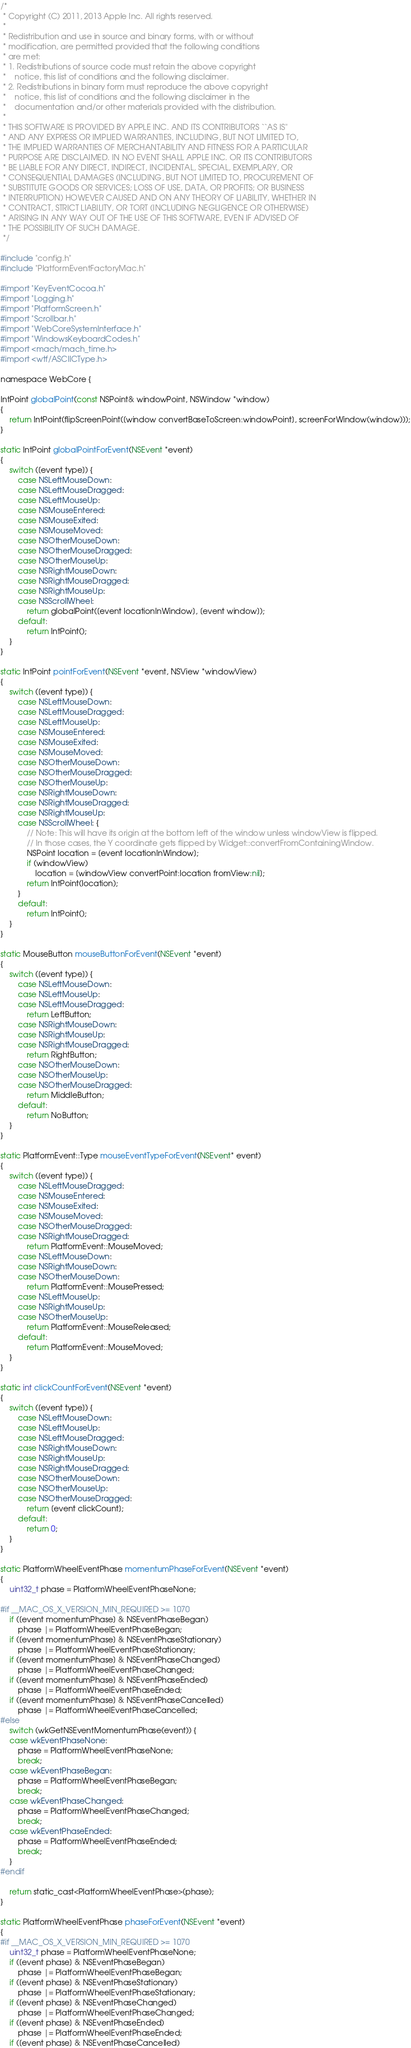Convert code to text. <code><loc_0><loc_0><loc_500><loc_500><_ObjectiveC_>/*
 * Copyright (C) 2011, 2013 Apple Inc. All rights reserved.
 *
 * Redistribution and use in source and binary forms, with or without
 * modification, are permitted provided that the following conditions
 * are met:
 * 1. Redistributions of source code must retain the above copyright
 *    notice, this list of conditions and the following disclaimer.
 * 2. Redistributions in binary form must reproduce the above copyright
 *    notice, this list of conditions and the following disclaimer in the
 *    documentation and/or other materials provided with the distribution.
 *
 * THIS SOFTWARE IS PROVIDED BY APPLE INC. AND ITS CONTRIBUTORS ``AS IS''
 * AND ANY EXPRESS OR IMPLIED WARRANTIES, INCLUDING, BUT NOT LIMITED TO,
 * THE IMPLIED WARRANTIES OF MERCHANTABILITY AND FITNESS FOR A PARTICULAR
 * PURPOSE ARE DISCLAIMED. IN NO EVENT SHALL APPLE INC. OR ITS CONTRIBUTORS
 * BE LIABLE FOR ANY DIRECT, INDIRECT, INCIDENTAL, SPECIAL, EXEMPLARY, OR
 * CONSEQUENTIAL DAMAGES (INCLUDING, BUT NOT LIMITED TO, PROCUREMENT OF
 * SUBSTITUTE GOODS OR SERVICES; LOSS OF USE, DATA, OR PROFITS; OR BUSINESS
 * INTERRUPTION) HOWEVER CAUSED AND ON ANY THEORY OF LIABILITY, WHETHER IN
 * CONTRACT, STRICT LIABILITY, OR TORT (INCLUDING NEGLIGENCE OR OTHERWISE)
 * ARISING IN ANY WAY OUT OF THE USE OF THIS SOFTWARE, EVEN IF ADVISED OF
 * THE POSSIBILITY OF SUCH DAMAGE.
 */

#include "config.h"
#include "PlatformEventFactoryMac.h"

#import "KeyEventCocoa.h"
#import "Logging.h"
#import "PlatformScreen.h"
#import "Scrollbar.h"
#import "WebCoreSystemInterface.h"
#import "WindowsKeyboardCodes.h"
#import <mach/mach_time.h>
#import <wtf/ASCIICType.h>

namespace WebCore {

IntPoint globalPoint(const NSPoint& windowPoint, NSWindow *window)
{
    return IntPoint(flipScreenPoint([window convertBaseToScreen:windowPoint], screenForWindow(window)));
}

static IntPoint globalPointForEvent(NSEvent *event)
{
    switch ([event type]) {
        case NSLeftMouseDown:
        case NSLeftMouseDragged:
        case NSLeftMouseUp:
        case NSMouseEntered:
        case NSMouseExited:
        case NSMouseMoved:
        case NSOtherMouseDown:
        case NSOtherMouseDragged:
        case NSOtherMouseUp:
        case NSRightMouseDown:
        case NSRightMouseDragged:
        case NSRightMouseUp:
        case NSScrollWheel:
            return globalPoint([event locationInWindow], [event window]);
        default:
            return IntPoint();
    }
}

static IntPoint pointForEvent(NSEvent *event, NSView *windowView)
{
    switch ([event type]) {
        case NSLeftMouseDown:
        case NSLeftMouseDragged:
        case NSLeftMouseUp:
        case NSMouseEntered:
        case NSMouseExited:
        case NSMouseMoved:
        case NSOtherMouseDown:
        case NSOtherMouseDragged:
        case NSOtherMouseUp:
        case NSRightMouseDown:
        case NSRightMouseDragged:
        case NSRightMouseUp:
        case NSScrollWheel: {
            // Note: This will have its origin at the bottom left of the window unless windowView is flipped.
            // In those cases, the Y coordinate gets flipped by Widget::convertFromContainingWindow.
            NSPoint location = [event locationInWindow];
            if (windowView)
                location = [windowView convertPoint:location fromView:nil];
            return IntPoint(location);
        }
        default:
            return IntPoint();
    }
}

static MouseButton mouseButtonForEvent(NSEvent *event)
{
    switch ([event type]) {
        case NSLeftMouseDown:
        case NSLeftMouseUp:
        case NSLeftMouseDragged:
            return LeftButton;
        case NSRightMouseDown:
        case NSRightMouseUp:
        case NSRightMouseDragged:
            return RightButton;
        case NSOtherMouseDown:
        case NSOtherMouseUp:
        case NSOtherMouseDragged:
            return MiddleButton;
        default:
            return NoButton;
    }
}

static PlatformEvent::Type mouseEventTypeForEvent(NSEvent* event)
{
    switch ([event type]) {
        case NSLeftMouseDragged:
        case NSMouseEntered:
        case NSMouseExited:
        case NSMouseMoved:
        case NSOtherMouseDragged:
        case NSRightMouseDragged:
            return PlatformEvent::MouseMoved;
        case NSLeftMouseDown:
        case NSRightMouseDown:
        case NSOtherMouseDown:
            return PlatformEvent::MousePressed;
        case NSLeftMouseUp:
        case NSRightMouseUp:
        case NSOtherMouseUp:
            return PlatformEvent::MouseReleased;
        default:
            return PlatformEvent::MouseMoved;
    }
}

static int clickCountForEvent(NSEvent *event)
{
    switch ([event type]) {
        case NSLeftMouseDown:
        case NSLeftMouseUp:
        case NSLeftMouseDragged:
        case NSRightMouseDown:
        case NSRightMouseUp:
        case NSRightMouseDragged:
        case NSOtherMouseDown:
        case NSOtherMouseUp:
        case NSOtherMouseDragged:
            return [event clickCount];
        default:
            return 0;
    }
}

static PlatformWheelEventPhase momentumPhaseForEvent(NSEvent *event)
{
    uint32_t phase = PlatformWheelEventPhaseNone;

#if __MAC_OS_X_VERSION_MIN_REQUIRED >= 1070
    if ([event momentumPhase] & NSEventPhaseBegan)
        phase |= PlatformWheelEventPhaseBegan;
    if ([event momentumPhase] & NSEventPhaseStationary)
        phase |= PlatformWheelEventPhaseStationary;
    if ([event momentumPhase] & NSEventPhaseChanged)
        phase |= PlatformWheelEventPhaseChanged;
    if ([event momentumPhase] & NSEventPhaseEnded)
        phase |= PlatformWheelEventPhaseEnded;
    if ([event momentumPhase] & NSEventPhaseCancelled)
        phase |= PlatformWheelEventPhaseCancelled;
#else
    switch (wkGetNSEventMomentumPhase(event)) {
    case wkEventPhaseNone:
        phase = PlatformWheelEventPhaseNone;
        break;
    case wkEventPhaseBegan:
        phase = PlatformWheelEventPhaseBegan;
        break;
    case wkEventPhaseChanged:
        phase = PlatformWheelEventPhaseChanged;
        break;
    case wkEventPhaseEnded:
        phase = PlatformWheelEventPhaseEnded;
        break;
    }
#endif

    return static_cast<PlatformWheelEventPhase>(phase);
}

static PlatformWheelEventPhase phaseForEvent(NSEvent *event)
{
#if __MAC_OS_X_VERSION_MIN_REQUIRED >= 1070
    uint32_t phase = PlatformWheelEventPhaseNone; 
    if ([event phase] & NSEventPhaseBegan)
        phase |= PlatformWheelEventPhaseBegan;
    if ([event phase] & NSEventPhaseStationary)
        phase |= PlatformWheelEventPhaseStationary;
    if ([event phase] & NSEventPhaseChanged)
        phase |= PlatformWheelEventPhaseChanged;
    if ([event phase] & NSEventPhaseEnded)
        phase |= PlatformWheelEventPhaseEnded;
    if ([event phase] & NSEventPhaseCancelled)</code> 